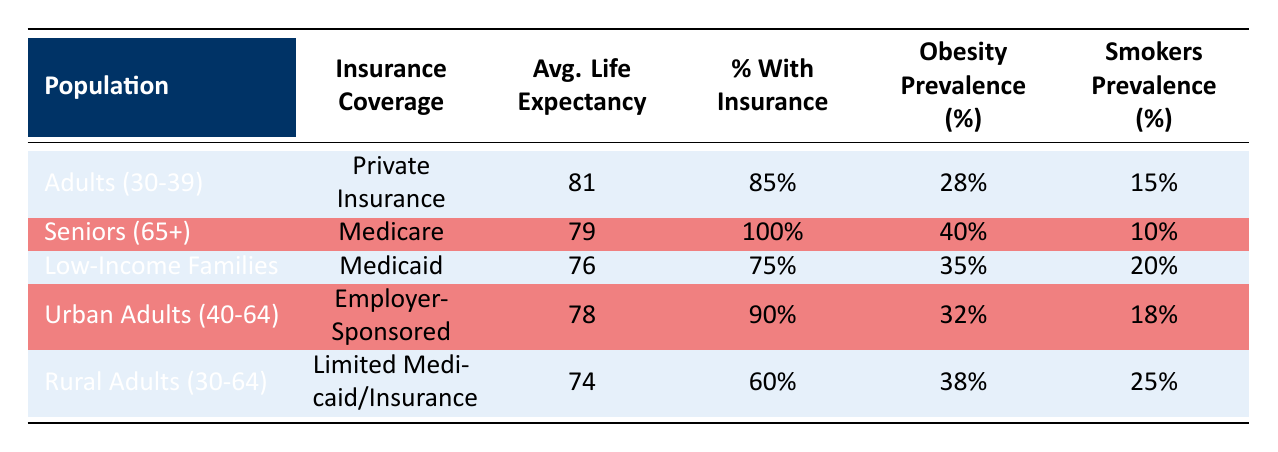What is the average life expectancy for adults aged 30-39 with private insurance? The table states that for adults aged 30-39 with private insurance, the average life expectancy is directly given as 81 years.
Answer: 81 How many percent of seniors aged 65 and older have insurance coverage? The table specifies that 100% of seniors aged 65 and older are covered by Medicare.
Answer: 100% What is the difference in average life expectancy between rural adults (ages 30-64) and seniors (ages 65+)? The average life expectancy for rural adults aged 30-64 is 74 years and for seniors aged 65+ it is 79 years. The difference is 79 - 74 = 5 years.
Answer: 5 Is it true that the prevalence of obesity is higher in low-income families compared to urban adults aged 40-64? The table shows that the prevalence of obesity in low-income families is 35% and for urban adults aged 40-64 it is 32%. Since 35% is greater than 32%, the statement is true.
Answer: Yes Which population has the lowest percentage with insurance coverage, and what is that percentage? By examining the table, rural adults aged 30-64 have the lowest insurance coverage at 60%.
Answer: 60% 